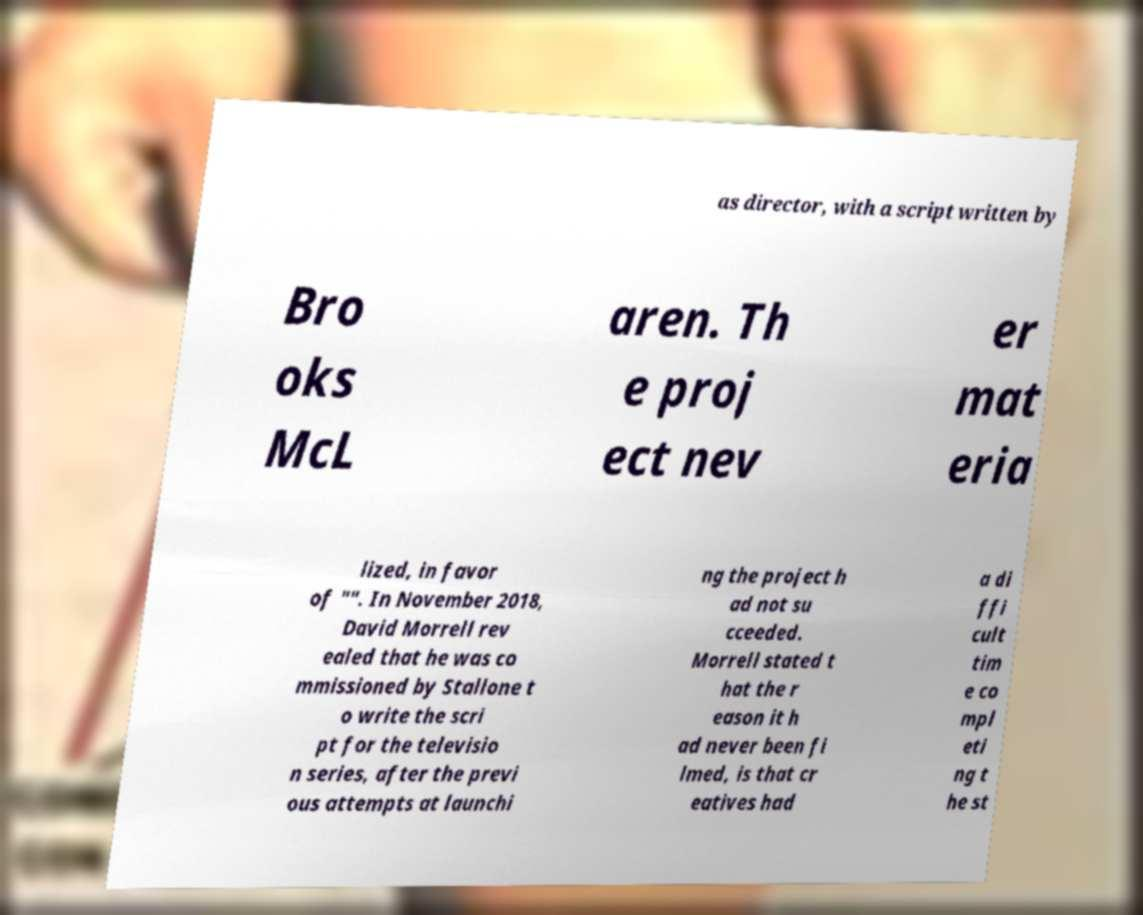Please read and relay the text visible in this image. What does it say? as director, with a script written by Bro oks McL aren. Th e proj ect nev er mat eria lized, in favor of "". In November 2018, David Morrell rev ealed that he was co mmissioned by Stallone t o write the scri pt for the televisio n series, after the previ ous attempts at launchi ng the project h ad not su cceeded. Morrell stated t hat the r eason it h ad never been fi lmed, is that cr eatives had a di ffi cult tim e co mpl eti ng t he st 